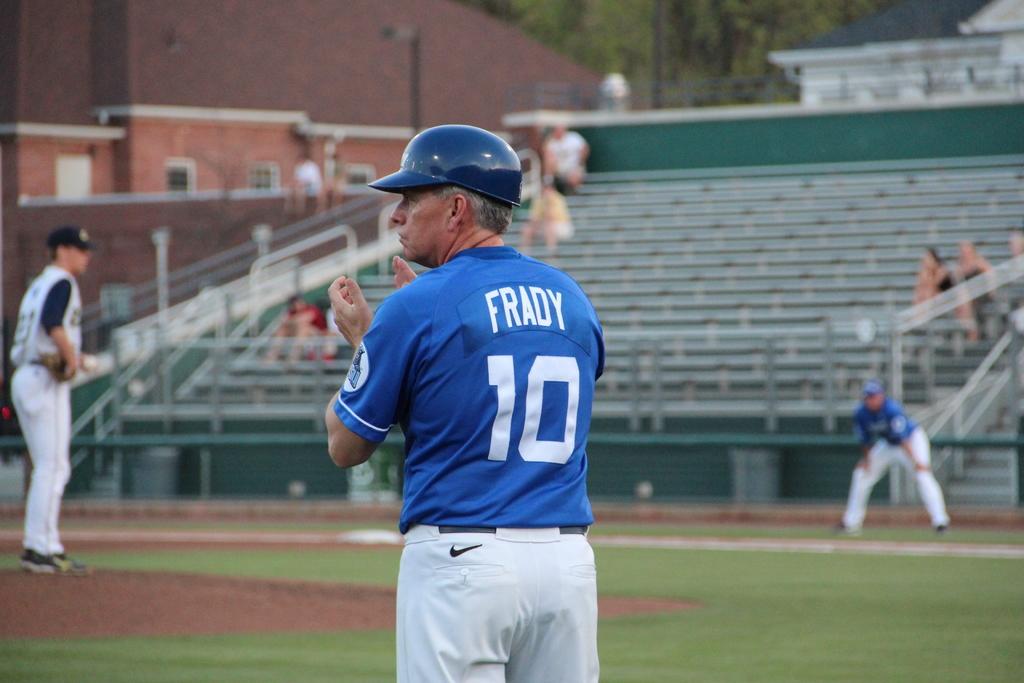What is the name of player number 10?
Offer a very short reply. Frady. 